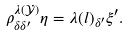<formula> <loc_0><loc_0><loc_500><loc_500>\rho ^ { \lambda ( \mathcal { Y } ) } _ { \delta \delta ^ { \prime } } \eta = \lambda ( l ) _ { \delta ^ { \prime } } \xi ^ { \prime } .</formula> 